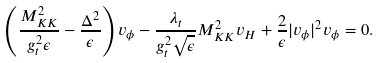<formula> <loc_0><loc_0><loc_500><loc_500>\left ( \frac { M _ { K K } ^ { 2 } } { g _ { t } ^ { 2 } \epsilon } - \frac { \Delta ^ { 2 } } { \epsilon } \right ) v _ { \phi } - \frac { \lambda _ { t } } { g ^ { 2 } _ { t } \sqrt { \epsilon } } M _ { K K } ^ { 2 } v _ { H } + \frac { 2 } { \epsilon } | v _ { \phi } | ^ { 2 } v _ { \phi } = 0 .</formula> 